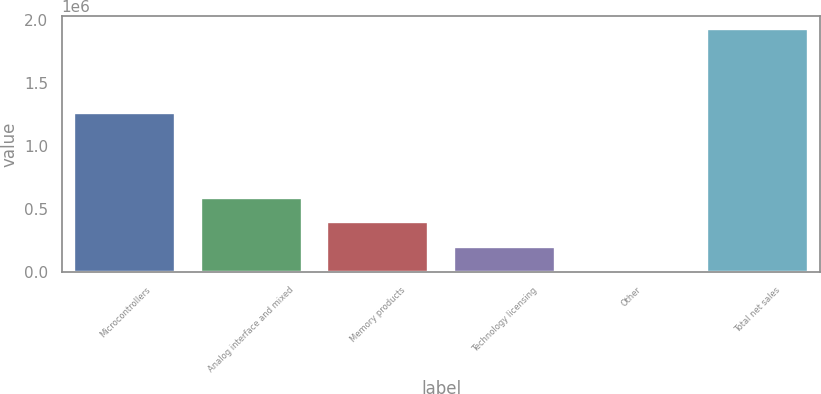Convert chart. <chart><loc_0><loc_0><loc_500><loc_500><bar_chart><fcel>Microcontrollers<fcel>Analog interface and mixed<fcel>Memory products<fcel>Technology licensing<fcel>Other<fcel>Total net sales<nl><fcel>1.26099e+06<fcel>588422<fcel>396595<fcel>204767<fcel>12939<fcel>1.93122e+06<nl></chart> 